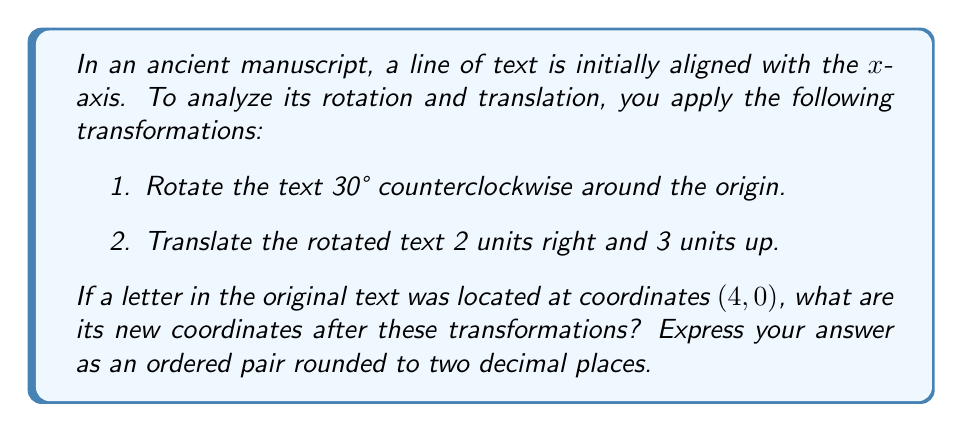Help me with this question. To solve this problem, we'll use coordinate transformations in the following steps:

1. Rotation:
The rotation matrix for a counterclockwise rotation by angle θ is:
$$R(\theta) = \begin{pmatrix} \cos\theta & -\sin\theta \\ \sin\theta & \cos\theta \end{pmatrix}$$

For a 30° rotation, θ = 30° = π/6 radians. Let's call our initial point P(4, 0).

$$\begin{pmatrix} x' \\ y' \end{pmatrix} = \begin{pmatrix} \cos(π/6) & -\sin(π/6) \\ \sin(π/6) & \cos(π/6) \end{pmatrix} \begin{pmatrix} 4 \\ 0 \end{pmatrix}$$

$$\begin{pmatrix} x' \\ y' \end{pmatrix} = \begin{pmatrix} 4\cos(π/6) \\ 4\sin(π/6) \end{pmatrix}$$

$$x' = 4\cos(π/6) = 4 \cdot \frac{\sqrt{3}}{2} = 2\sqrt{3} \approx 3.4641$$
$$y' = 4\sin(π/6) = 4 \cdot \frac{1}{2} = 2$$

After rotation, the point is at approximately (3.4641, 2).

2. Translation:
To translate 2 units right and 3 units up, we add these values to our rotated coordinates:

$$x'' = x' + 2 = 3.4641 + 2 = 5.4641$$
$$y'' = y' + 3 = 2 + 3 = 5$$

Therefore, the final coordinates are approximately (5.46, 5.00) when rounded to two decimal places.
Answer: (5.46, 5.00) 